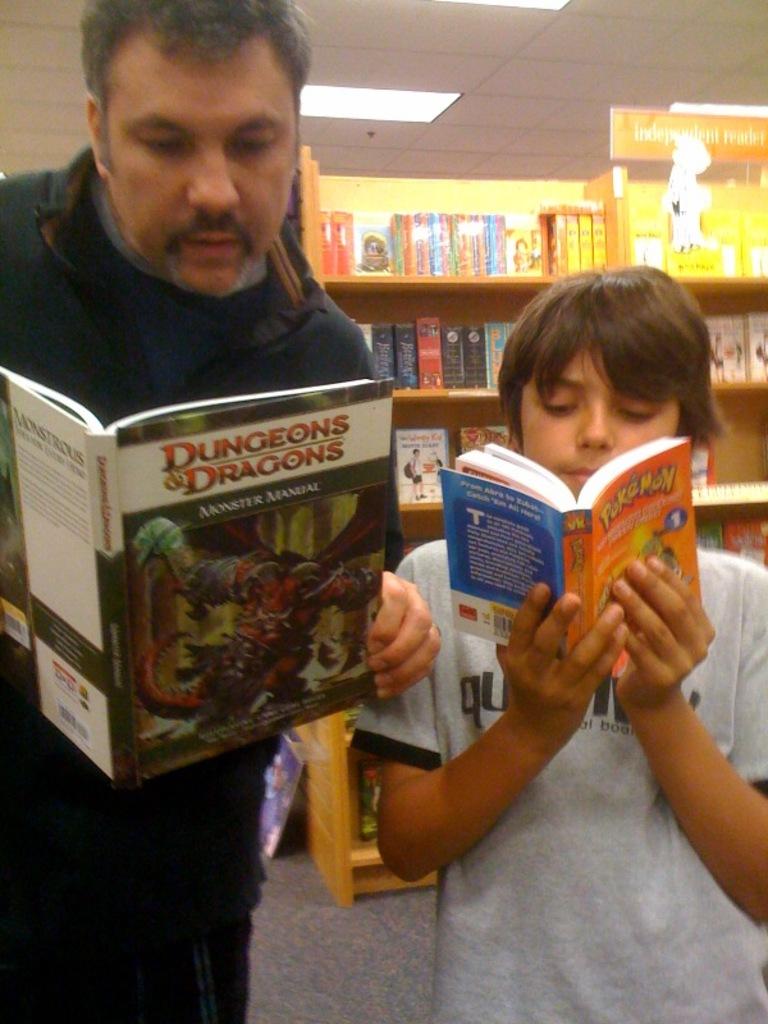What is the title of the book the father is reading?
Give a very brief answer. Dungeons and dragons. What type of "manual" is the man reading?
Your answer should be compact. Dungeons and dragons. 